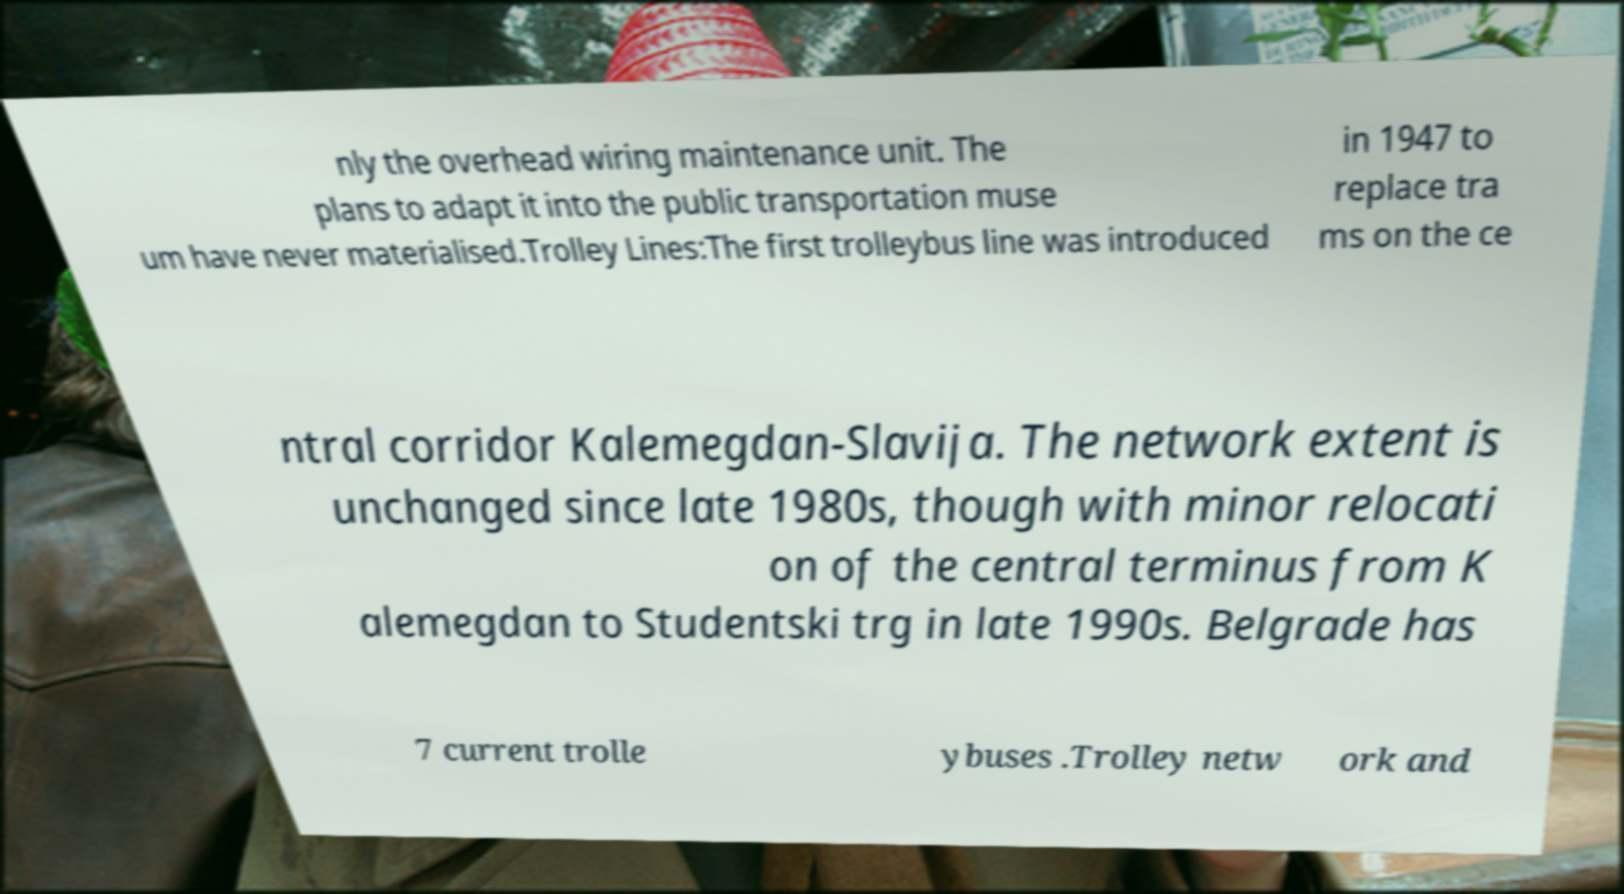Can you accurately transcribe the text from the provided image for me? nly the overhead wiring maintenance unit. The plans to adapt it into the public transportation muse um have never materialised.Trolley Lines:The first trolleybus line was introduced in 1947 to replace tra ms on the ce ntral corridor Kalemegdan-Slavija. The network extent is unchanged since late 1980s, though with minor relocati on of the central terminus from K alemegdan to Studentski trg in late 1990s. Belgrade has 7 current trolle ybuses .Trolley netw ork and 